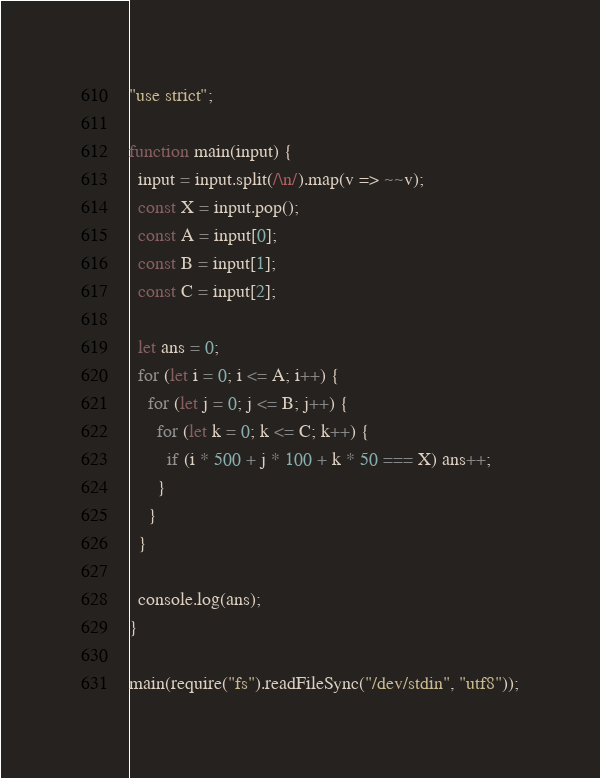Convert code to text. <code><loc_0><loc_0><loc_500><loc_500><_JavaScript_>"use strict";

function main(input) {
  input = input.split(/\n/).map(v => ~~v);
  const X = input.pop();
  const A = input[0];
  const B = input[1];
  const C = input[2];

  let ans = 0;
  for (let i = 0; i <= A; i++) {
    for (let j = 0; j <= B; j++) {
      for (let k = 0; k <= C; k++) {
        if (i * 500 + j * 100 + k * 50 === X) ans++;
      }
    }
  }

  console.log(ans);
}

main(require("fs").readFileSync("/dev/stdin", "utf8"));
</code> 